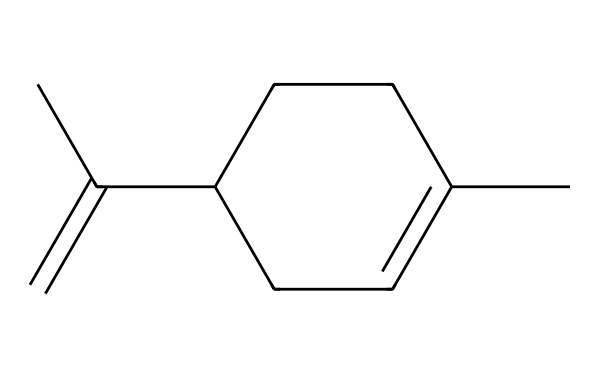¿Qué tipo de compuesto es este? Este compuesto tiene una cadena de carbono sin enlaces dobles adicionales en su estructura principal, colocándolo en la categoría de compuestos alifáticos.
Answer: alifático ¿Cuántos átomos de carbono hay en este compuesto? Al observar la estructura, se cuentan un total de seis átomos de carbono en la cadena principal y dos en los grupos laterales, sumando ocho en total.
Answer: ocho ¿Cuál es el grupo funcional predominante? Este compuesto muestra un doble enlace en su estructura, lo que indica que su principal grupo funcional es un alceno.
Answer: alceno ¿Cuántos enlaces dobles tiene este compuesto? Observando la estructura, se identifica un número total de un enlace doble dentro de la cadena, confirmando la presencia de un alceno.
Answer: uno ¿Qué tipo de interacciones intermoleculares son predominantes en este compuesto? Dado que este es un compuesto alifático y tiene solo enlace carbono-carbono y carbono-hidrógeno, las interacciones predominantes son las fuerzas de Van der Waals.
Answer: fuerzas de Van der Waals ¿Por qué este compuesto puede ser considerado como un disolvente ecológico? Alifáticos como este tienen menor toxicidad en comparación con solventes aromáticos, lo que los hace más seguros y preferibles en aplicaciones sostenibles.
Answer: menor toxicidad 